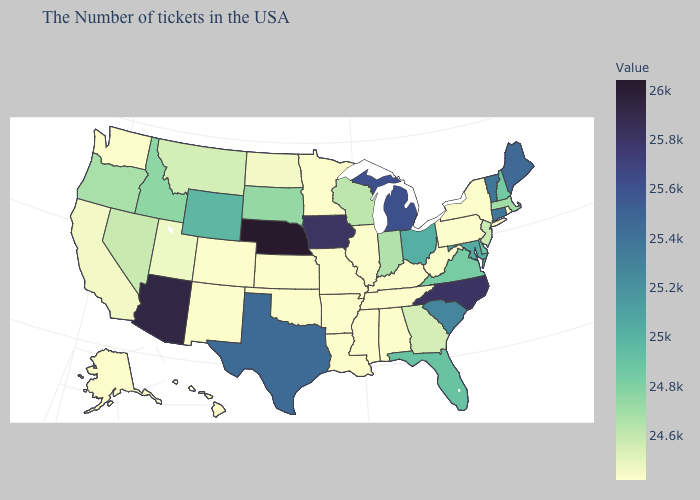Does Oklahoma have the lowest value in the South?
Answer briefly. Yes. Which states have the highest value in the USA?
Be succinct. Nebraska. Which states hav the highest value in the South?
Be succinct. North Carolina. Does Nebraska have the highest value in the USA?
Write a very short answer. Yes. 